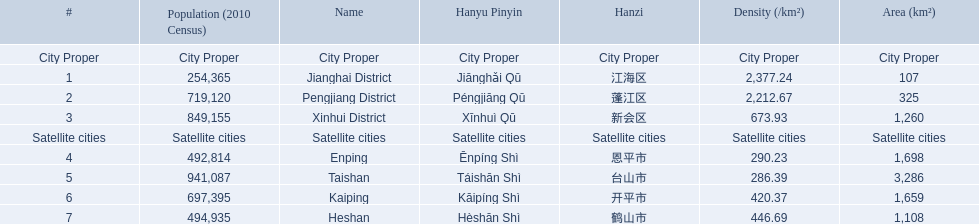What are the satellite cities of jiangmen? Enping, Taishan, Kaiping, Heshan. Of these cities, which has the highest density? Taishan. 